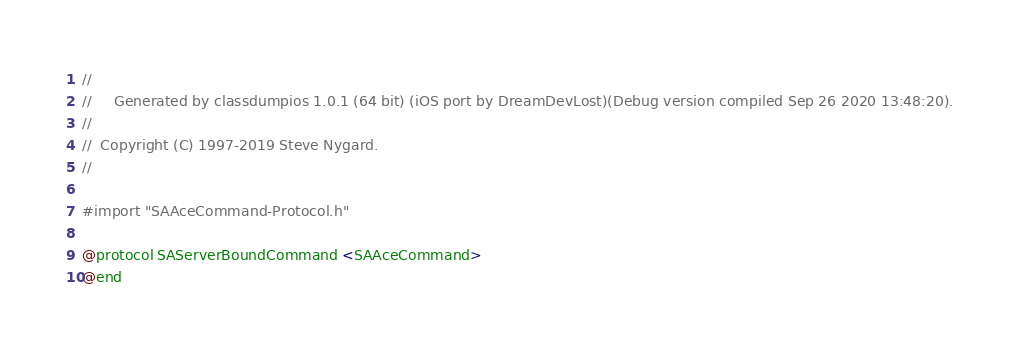<code> <loc_0><loc_0><loc_500><loc_500><_C_>//
//     Generated by classdumpios 1.0.1 (64 bit) (iOS port by DreamDevLost)(Debug version compiled Sep 26 2020 13:48:20).
//
//  Copyright (C) 1997-2019 Steve Nygard.
//

#import "SAAceCommand-Protocol.h"

@protocol SAServerBoundCommand <SAAceCommand>
@end

</code> 